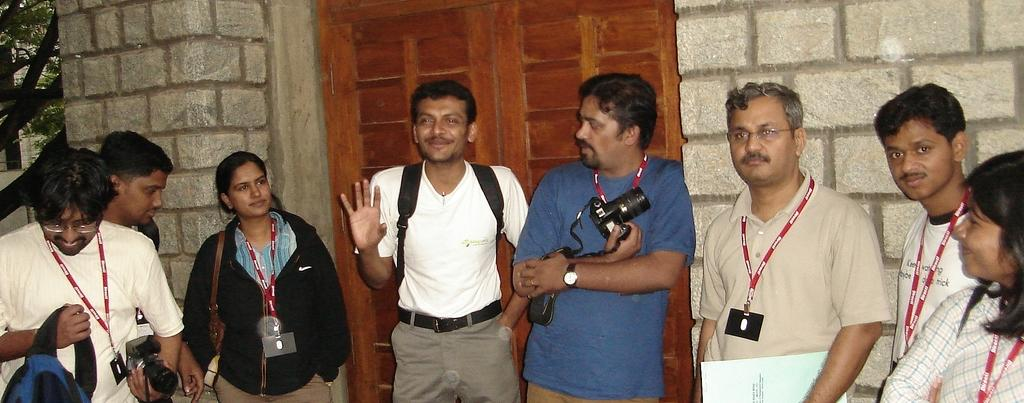How many buildings are in the image? There is one building in the image. What other object can be seen in the image besides the building? There is one tree in the image. What type of door is on the building? There is a wooden door in the image. How many people are in the image? Eight people are standing in the image. What are some people doing with their bags? Some people are wearing bags. What are some people holding in the image? Some people are holding objects. Can you see any bananas being smashed with paste in the image? There is no mention of bananas, smashing, or paste in the image. 